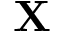Convert formula to latex. <formula><loc_0><loc_0><loc_500><loc_500>X</formula> 